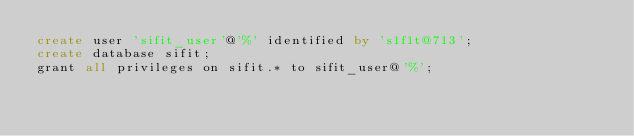Convert code to text. <code><loc_0><loc_0><loc_500><loc_500><_SQL_>create user 'sifit_user'@'%' identified by 's1f1t@713';
create database sifit;
grant all privileges on sifit.* to sifit_user@'%';
</code> 